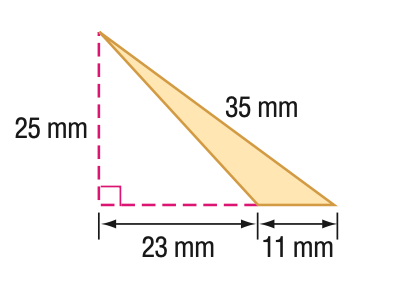Question: Find the perimeter of the triangle. Round to the nearest tenth if necessary.
Choices:
A. 70.0
B. 75.0
C. 80.0
D. 85.0
Answer with the letter. Answer: C Question: Find the area of the triangle. Round to the nearest tenth if necessary.
Choices:
A. 137.5
B. 150
C. 265
D. 287.5
Answer with the letter. Answer: A 